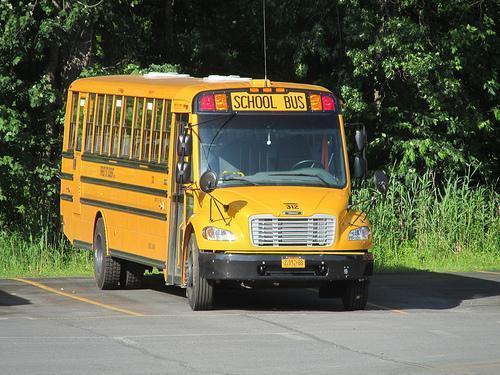How many buses are there?
Give a very brief answer. 1. 